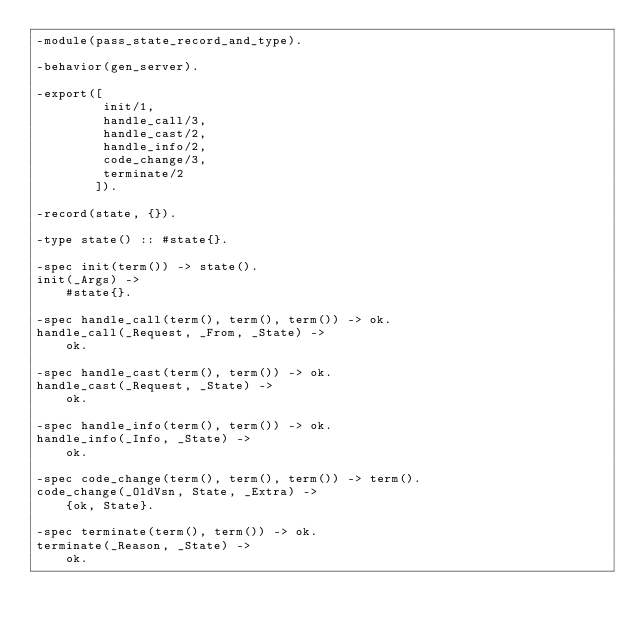Convert code to text. <code><loc_0><loc_0><loc_500><loc_500><_Erlang_>-module(pass_state_record_and_type).

-behavior(gen_server).

-export([
         init/1,
         handle_call/3,
         handle_cast/2,
         handle_info/2,
         code_change/3,
         terminate/2
        ]).

-record(state, {}).

-type state() :: #state{}.

-spec init(term()) -> state().
init(_Args) ->
    #state{}.

-spec handle_call(term(), term(), term()) -> ok.
handle_call(_Request, _From, _State) ->
    ok.

-spec handle_cast(term(), term()) -> ok.
handle_cast(_Request, _State) ->
    ok.

-spec handle_info(term(), term()) -> ok.
handle_info(_Info, _State) ->
    ok.

-spec code_change(term(), term(), term()) -> term().
code_change(_OldVsn, State, _Extra) ->
    {ok, State}.

-spec terminate(term(), term()) -> ok.
terminate(_Reason, _State) ->
    ok.
</code> 